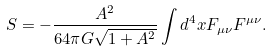Convert formula to latex. <formula><loc_0><loc_0><loc_500><loc_500>S = - \frac { A ^ { 2 } } { 6 4 \pi G \sqrt { 1 + A ^ { 2 } } } \int d ^ { 4 } x F _ { \mu \nu } F ^ { \mu \nu } .</formula> 